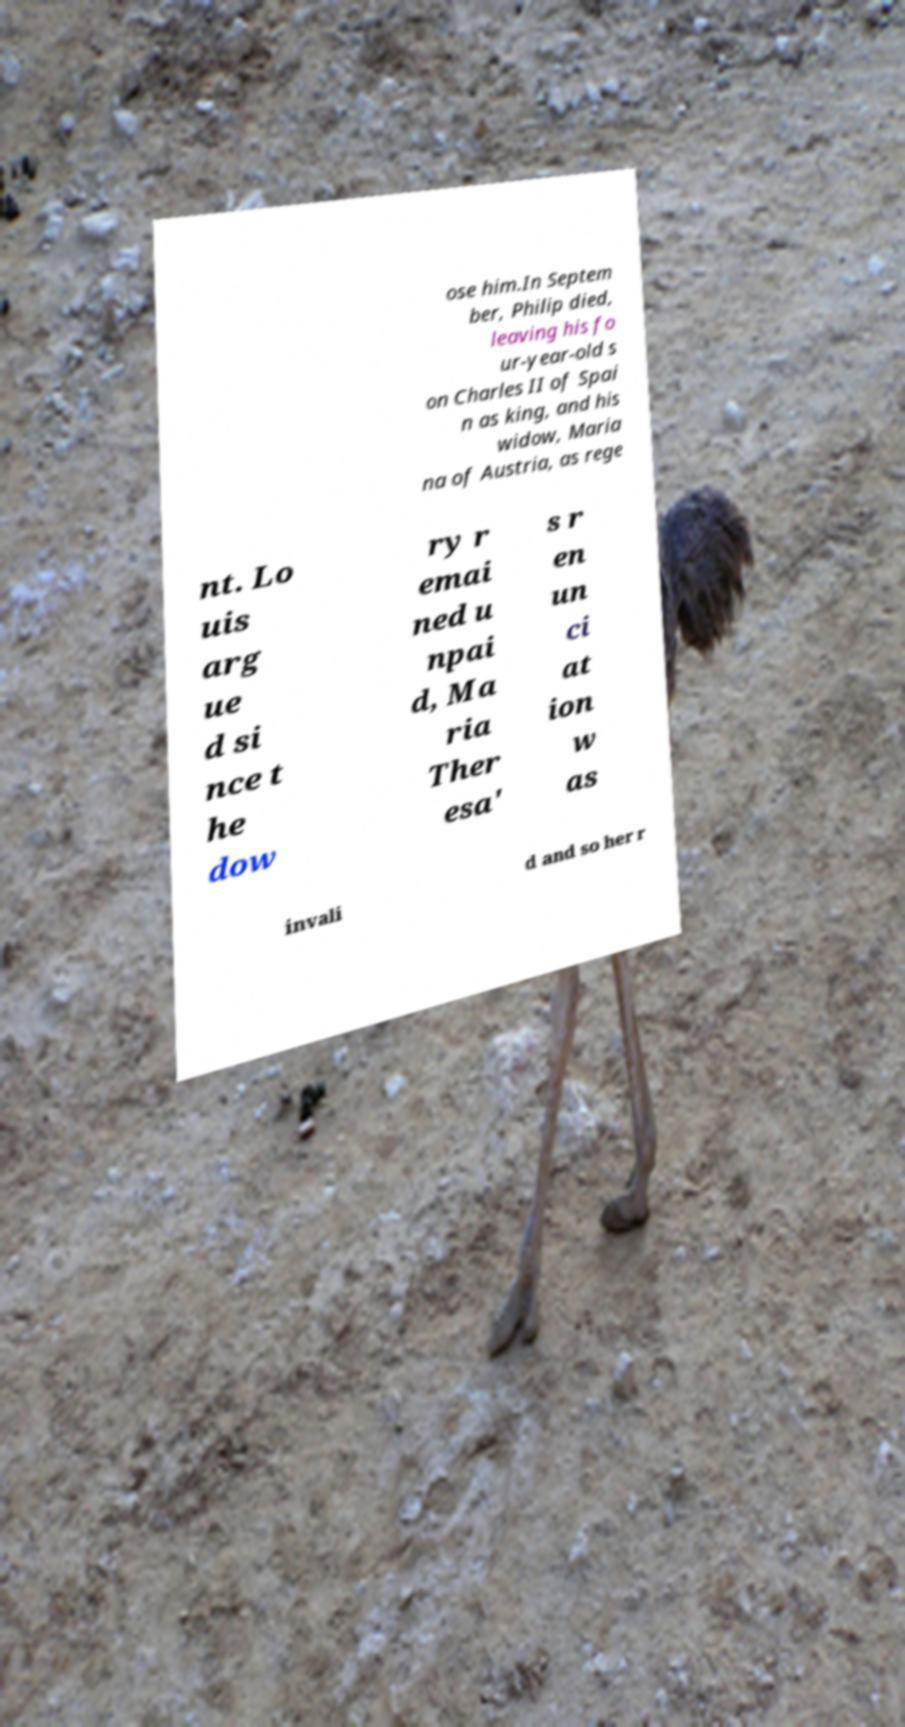I need the written content from this picture converted into text. Can you do that? ose him.In Septem ber, Philip died, leaving his fo ur-year-old s on Charles II of Spai n as king, and his widow, Maria na of Austria, as rege nt. Lo uis arg ue d si nce t he dow ry r emai ned u npai d, Ma ria Ther esa' s r en un ci at ion w as invali d and so her r 